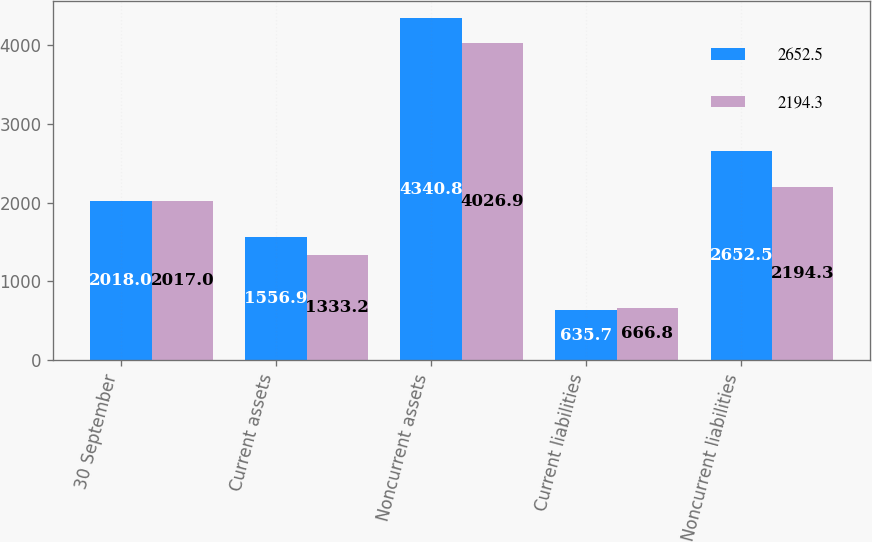Convert chart. <chart><loc_0><loc_0><loc_500><loc_500><stacked_bar_chart><ecel><fcel>30 September<fcel>Current assets<fcel>Noncurrent assets<fcel>Current liabilities<fcel>Noncurrent liabilities<nl><fcel>2652.5<fcel>2018<fcel>1556.9<fcel>4340.8<fcel>635.7<fcel>2652.5<nl><fcel>2194.3<fcel>2017<fcel>1333.2<fcel>4026.9<fcel>666.8<fcel>2194.3<nl></chart> 